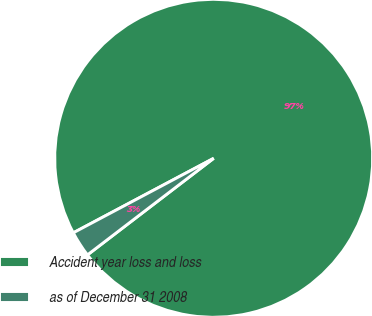<chart> <loc_0><loc_0><loc_500><loc_500><pie_chart><fcel>Accident year loss and loss<fcel>as of December 31 2008<nl><fcel>97.37%<fcel>2.63%<nl></chart> 